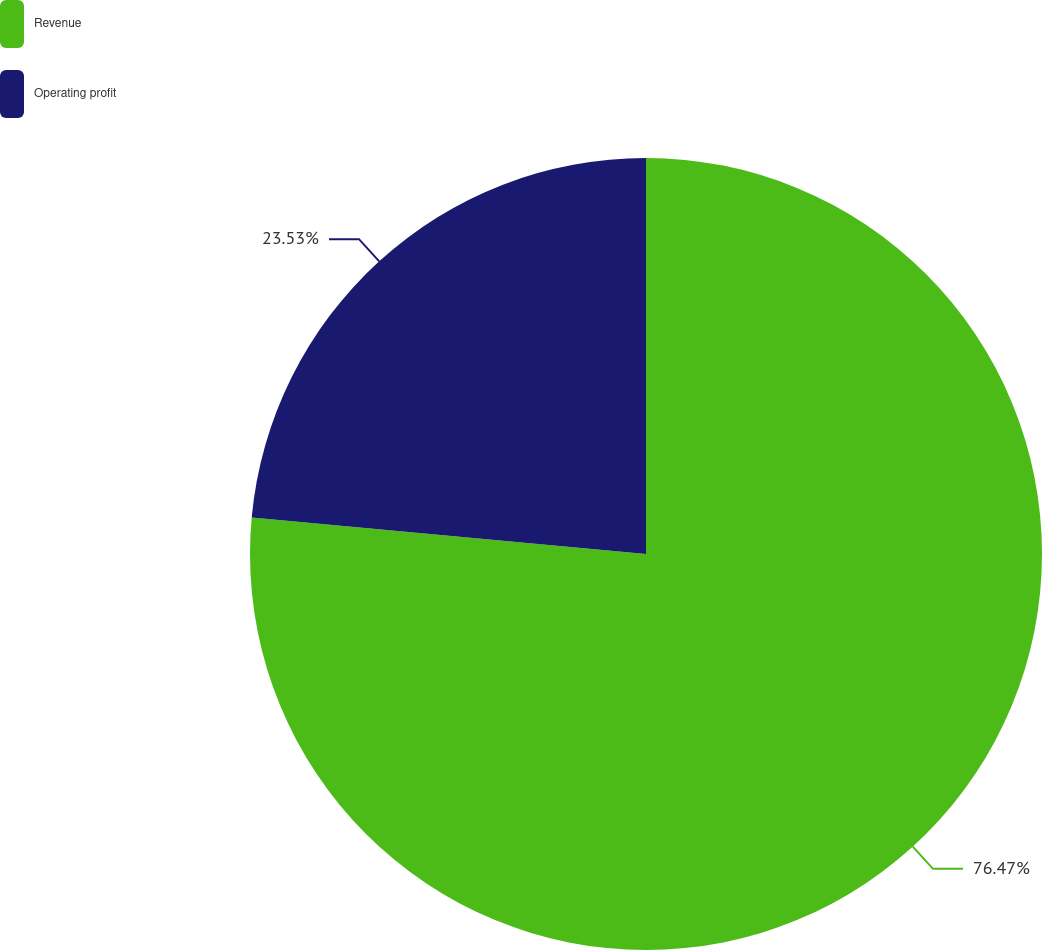Convert chart. <chart><loc_0><loc_0><loc_500><loc_500><pie_chart><fcel>Revenue<fcel>Operating profit<nl><fcel>76.47%<fcel>23.53%<nl></chart> 